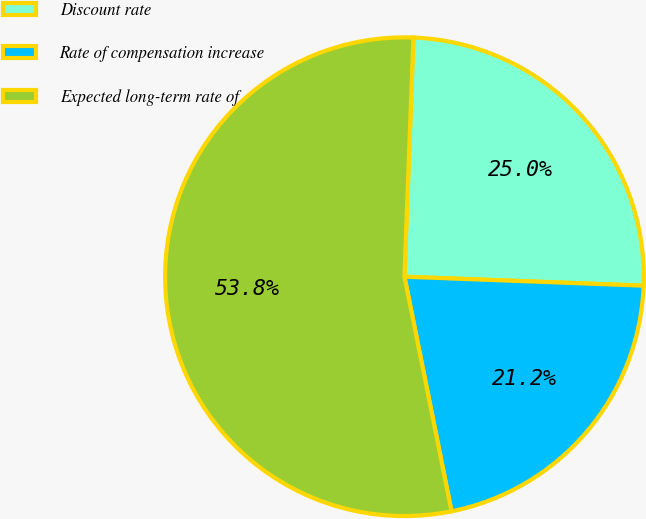Convert chart to OTSL. <chart><loc_0><loc_0><loc_500><loc_500><pie_chart><fcel>Discount rate<fcel>Rate of compensation increase<fcel>Expected long-term rate of<nl><fcel>25.0%<fcel>21.25%<fcel>53.75%<nl></chart> 